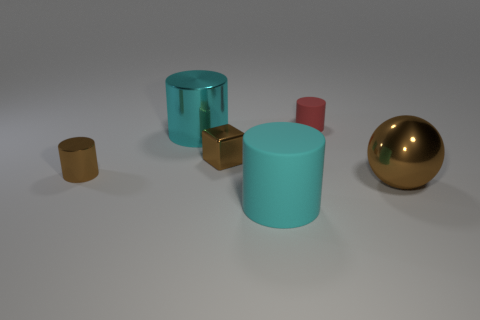There is a big matte object that is the same shape as the small red object; what is its color?
Give a very brief answer. Cyan. How many tiny green things have the same shape as the big rubber thing?
Keep it short and to the point. 0. What is the material of the tiny cube that is the same color as the big metallic ball?
Offer a terse response. Metal. How many large cyan cylinders are there?
Offer a terse response. 2. Are there any big gray things that have the same material as the tiny brown cylinder?
Give a very brief answer. No. There is a shiny cube that is the same color as the metallic ball; what is its size?
Keep it short and to the point. Small. There is a matte thing in front of the small matte object; does it have the same size as the ball that is on the right side of the small metal cube?
Provide a succinct answer. Yes. What size is the brown metal thing that is in front of the tiny shiny cylinder?
Your response must be concise. Large. Are there any shiny spheres that have the same color as the tiny rubber object?
Your response must be concise. No. There is a rubber thing on the left side of the tiny rubber cylinder; is there a small red matte cylinder in front of it?
Give a very brief answer. No. 